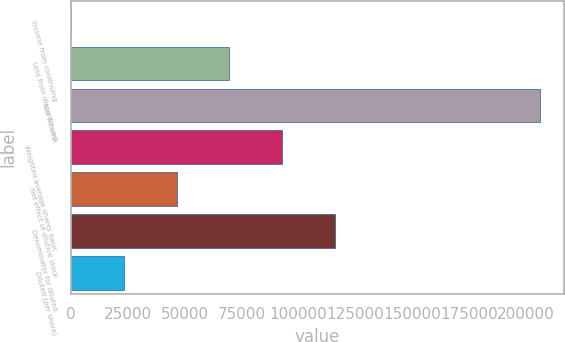<chart> <loc_0><loc_0><loc_500><loc_500><bar_chart><fcel>Income from continuing<fcel>Loss from discontinued<fcel>Net income<fcel>Weighted average shares basic<fcel>Net effect of dilutive stock<fcel>Denominator for diluted<fcel>Diluted (per share)<nl><fcel>0.36<fcel>69765.8<fcel>206402<fcel>93021<fcel>46510.7<fcel>116276<fcel>23255.5<nl></chart> 